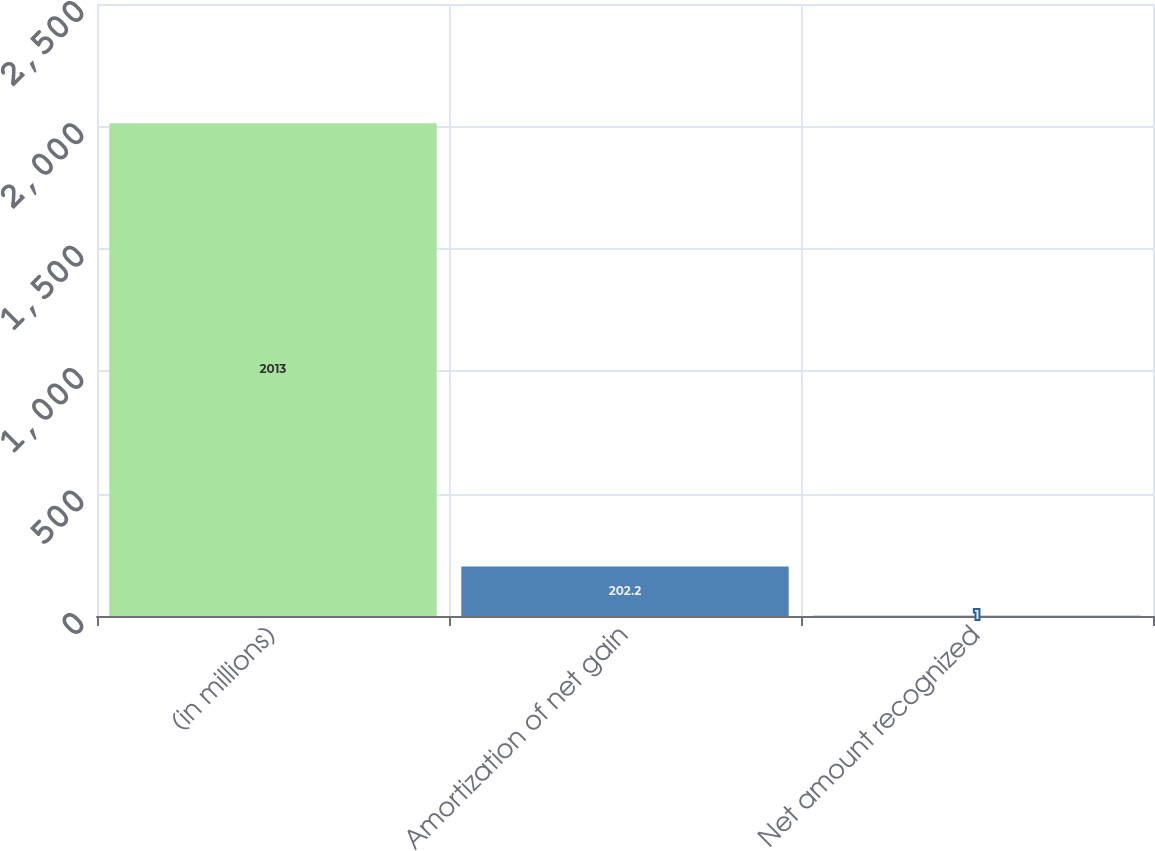Convert chart to OTSL. <chart><loc_0><loc_0><loc_500><loc_500><bar_chart><fcel>(in millions)<fcel>Amortization of net gain<fcel>Net amount recognized<nl><fcel>2013<fcel>202.2<fcel>1<nl></chart> 